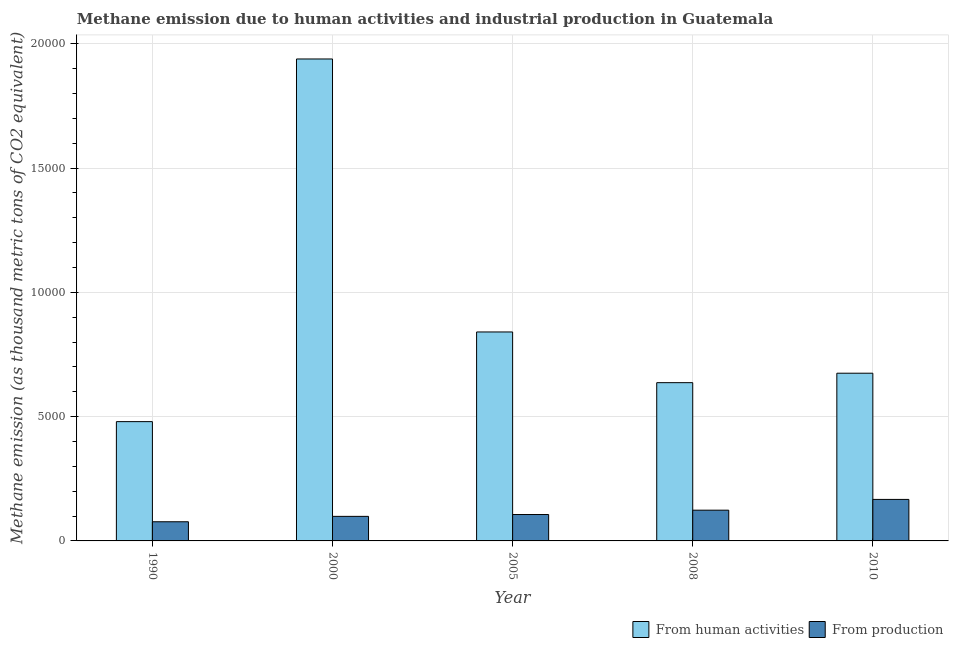How many different coloured bars are there?
Keep it short and to the point. 2. Are the number of bars per tick equal to the number of legend labels?
Your response must be concise. Yes. Are the number of bars on each tick of the X-axis equal?
Keep it short and to the point. Yes. How many bars are there on the 5th tick from the right?
Keep it short and to the point. 2. What is the label of the 3rd group of bars from the left?
Offer a very short reply. 2005. What is the amount of emissions from human activities in 2008?
Give a very brief answer. 6365.4. Across all years, what is the maximum amount of emissions from human activities?
Your response must be concise. 1.94e+04. Across all years, what is the minimum amount of emissions from human activities?
Give a very brief answer. 4798.4. In which year was the amount of emissions from human activities minimum?
Ensure brevity in your answer.  1990. What is the total amount of emissions from human activities in the graph?
Offer a very short reply. 4.57e+04. What is the difference between the amount of emissions from human activities in 2000 and that in 2005?
Ensure brevity in your answer.  1.10e+04. What is the difference between the amount of emissions from human activities in 2005 and the amount of emissions generated from industries in 2010?
Provide a short and direct response. 1659.2. What is the average amount of emissions from human activities per year?
Your answer should be compact. 9140. What is the ratio of the amount of emissions from human activities in 1990 to that in 2005?
Give a very brief answer. 0.57. Is the amount of emissions from human activities in 1990 less than that in 2000?
Give a very brief answer. Yes. Is the difference between the amount of emissions generated from industries in 1990 and 2008 greater than the difference between the amount of emissions from human activities in 1990 and 2008?
Make the answer very short. No. What is the difference between the highest and the second highest amount of emissions generated from industries?
Provide a short and direct response. 432.8. What is the difference between the highest and the lowest amount of emissions generated from industries?
Ensure brevity in your answer.  898.7. What does the 1st bar from the left in 1990 represents?
Offer a very short reply. From human activities. What does the 1st bar from the right in 1990 represents?
Offer a very short reply. From production. How many bars are there?
Make the answer very short. 10. What is the difference between two consecutive major ticks on the Y-axis?
Your answer should be compact. 5000. Are the values on the major ticks of Y-axis written in scientific E-notation?
Your answer should be very brief. No. Does the graph contain any zero values?
Make the answer very short. No. What is the title of the graph?
Your answer should be very brief. Methane emission due to human activities and industrial production in Guatemala. Does "Agricultural land" appear as one of the legend labels in the graph?
Your answer should be very brief. No. What is the label or title of the X-axis?
Your answer should be compact. Year. What is the label or title of the Y-axis?
Provide a succinct answer. Methane emission (as thousand metric tons of CO2 equivalent). What is the Methane emission (as thousand metric tons of CO2 equivalent) in From human activities in 1990?
Your response must be concise. 4798.4. What is the Methane emission (as thousand metric tons of CO2 equivalent) of From production in 1990?
Make the answer very short. 770.6. What is the Methane emission (as thousand metric tons of CO2 equivalent) in From human activities in 2000?
Keep it short and to the point. 1.94e+04. What is the Methane emission (as thousand metric tons of CO2 equivalent) of From production in 2000?
Your answer should be very brief. 987.9. What is the Methane emission (as thousand metric tons of CO2 equivalent) of From human activities in 2005?
Your answer should be very brief. 8404.9. What is the Methane emission (as thousand metric tons of CO2 equivalent) in From production in 2005?
Your answer should be very brief. 1062. What is the Methane emission (as thousand metric tons of CO2 equivalent) in From human activities in 2008?
Make the answer very short. 6365.4. What is the Methane emission (as thousand metric tons of CO2 equivalent) of From production in 2008?
Your answer should be compact. 1236.5. What is the Methane emission (as thousand metric tons of CO2 equivalent) of From human activities in 2010?
Provide a short and direct response. 6745.7. What is the Methane emission (as thousand metric tons of CO2 equivalent) in From production in 2010?
Your response must be concise. 1669.3. Across all years, what is the maximum Methane emission (as thousand metric tons of CO2 equivalent) of From human activities?
Your answer should be very brief. 1.94e+04. Across all years, what is the maximum Methane emission (as thousand metric tons of CO2 equivalent) of From production?
Provide a succinct answer. 1669.3. Across all years, what is the minimum Methane emission (as thousand metric tons of CO2 equivalent) of From human activities?
Make the answer very short. 4798.4. Across all years, what is the minimum Methane emission (as thousand metric tons of CO2 equivalent) of From production?
Your answer should be compact. 770.6. What is the total Methane emission (as thousand metric tons of CO2 equivalent) in From human activities in the graph?
Provide a succinct answer. 4.57e+04. What is the total Methane emission (as thousand metric tons of CO2 equivalent) of From production in the graph?
Offer a terse response. 5726.3. What is the difference between the Methane emission (as thousand metric tons of CO2 equivalent) in From human activities in 1990 and that in 2000?
Your response must be concise. -1.46e+04. What is the difference between the Methane emission (as thousand metric tons of CO2 equivalent) in From production in 1990 and that in 2000?
Keep it short and to the point. -217.3. What is the difference between the Methane emission (as thousand metric tons of CO2 equivalent) in From human activities in 1990 and that in 2005?
Your response must be concise. -3606.5. What is the difference between the Methane emission (as thousand metric tons of CO2 equivalent) of From production in 1990 and that in 2005?
Offer a terse response. -291.4. What is the difference between the Methane emission (as thousand metric tons of CO2 equivalent) of From human activities in 1990 and that in 2008?
Offer a terse response. -1567. What is the difference between the Methane emission (as thousand metric tons of CO2 equivalent) in From production in 1990 and that in 2008?
Offer a very short reply. -465.9. What is the difference between the Methane emission (as thousand metric tons of CO2 equivalent) in From human activities in 1990 and that in 2010?
Make the answer very short. -1947.3. What is the difference between the Methane emission (as thousand metric tons of CO2 equivalent) in From production in 1990 and that in 2010?
Your answer should be compact. -898.7. What is the difference between the Methane emission (as thousand metric tons of CO2 equivalent) of From human activities in 2000 and that in 2005?
Offer a terse response. 1.10e+04. What is the difference between the Methane emission (as thousand metric tons of CO2 equivalent) of From production in 2000 and that in 2005?
Keep it short and to the point. -74.1. What is the difference between the Methane emission (as thousand metric tons of CO2 equivalent) in From human activities in 2000 and that in 2008?
Your answer should be very brief. 1.30e+04. What is the difference between the Methane emission (as thousand metric tons of CO2 equivalent) in From production in 2000 and that in 2008?
Provide a succinct answer. -248.6. What is the difference between the Methane emission (as thousand metric tons of CO2 equivalent) of From human activities in 2000 and that in 2010?
Your response must be concise. 1.26e+04. What is the difference between the Methane emission (as thousand metric tons of CO2 equivalent) in From production in 2000 and that in 2010?
Your response must be concise. -681.4. What is the difference between the Methane emission (as thousand metric tons of CO2 equivalent) in From human activities in 2005 and that in 2008?
Keep it short and to the point. 2039.5. What is the difference between the Methane emission (as thousand metric tons of CO2 equivalent) of From production in 2005 and that in 2008?
Provide a short and direct response. -174.5. What is the difference between the Methane emission (as thousand metric tons of CO2 equivalent) in From human activities in 2005 and that in 2010?
Your response must be concise. 1659.2. What is the difference between the Methane emission (as thousand metric tons of CO2 equivalent) of From production in 2005 and that in 2010?
Give a very brief answer. -607.3. What is the difference between the Methane emission (as thousand metric tons of CO2 equivalent) of From human activities in 2008 and that in 2010?
Offer a very short reply. -380.3. What is the difference between the Methane emission (as thousand metric tons of CO2 equivalent) of From production in 2008 and that in 2010?
Ensure brevity in your answer.  -432.8. What is the difference between the Methane emission (as thousand metric tons of CO2 equivalent) of From human activities in 1990 and the Methane emission (as thousand metric tons of CO2 equivalent) of From production in 2000?
Provide a short and direct response. 3810.5. What is the difference between the Methane emission (as thousand metric tons of CO2 equivalent) in From human activities in 1990 and the Methane emission (as thousand metric tons of CO2 equivalent) in From production in 2005?
Provide a short and direct response. 3736.4. What is the difference between the Methane emission (as thousand metric tons of CO2 equivalent) of From human activities in 1990 and the Methane emission (as thousand metric tons of CO2 equivalent) of From production in 2008?
Offer a terse response. 3561.9. What is the difference between the Methane emission (as thousand metric tons of CO2 equivalent) in From human activities in 1990 and the Methane emission (as thousand metric tons of CO2 equivalent) in From production in 2010?
Your response must be concise. 3129.1. What is the difference between the Methane emission (as thousand metric tons of CO2 equivalent) of From human activities in 2000 and the Methane emission (as thousand metric tons of CO2 equivalent) of From production in 2005?
Offer a very short reply. 1.83e+04. What is the difference between the Methane emission (as thousand metric tons of CO2 equivalent) in From human activities in 2000 and the Methane emission (as thousand metric tons of CO2 equivalent) in From production in 2008?
Offer a very short reply. 1.81e+04. What is the difference between the Methane emission (as thousand metric tons of CO2 equivalent) in From human activities in 2000 and the Methane emission (as thousand metric tons of CO2 equivalent) in From production in 2010?
Offer a very short reply. 1.77e+04. What is the difference between the Methane emission (as thousand metric tons of CO2 equivalent) in From human activities in 2005 and the Methane emission (as thousand metric tons of CO2 equivalent) in From production in 2008?
Make the answer very short. 7168.4. What is the difference between the Methane emission (as thousand metric tons of CO2 equivalent) in From human activities in 2005 and the Methane emission (as thousand metric tons of CO2 equivalent) in From production in 2010?
Your response must be concise. 6735.6. What is the difference between the Methane emission (as thousand metric tons of CO2 equivalent) of From human activities in 2008 and the Methane emission (as thousand metric tons of CO2 equivalent) of From production in 2010?
Ensure brevity in your answer.  4696.1. What is the average Methane emission (as thousand metric tons of CO2 equivalent) in From human activities per year?
Keep it short and to the point. 9140. What is the average Methane emission (as thousand metric tons of CO2 equivalent) of From production per year?
Provide a succinct answer. 1145.26. In the year 1990, what is the difference between the Methane emission (as thousand metric tons of CO2 equivalent) in From human activities and Methane emission (as thousand metric tons of CO2 equivalent) in From production?
Your answer should be very brief. 4027.8. In the year 2000, what is the difference between the Methane emission (as thousand metric tons of CO2 equivalent) of From human activities and Methane emission (as thousand metric tons of CO2 equivalent) of From production?
Your response must be concise. 1.84e+04. In the year 2005, what is the difference between the Methane emission (as thousand metric tons of CO2 equivalent) in From human activities and Methane emission (as thousand metric tons of CO2 equivalent) in From production?
Provide a succinct answer. 7342.9. In the year 2008, what is the difference between the Methane emission (as thousand metric tons of CO2 equivalent) in From human activities and Methane emission (as thousand metric tons of CO2 equivalent) in From production?
Offer a very short reply. 5128.9. In the year 2010, what is the difference between the Methane emission (as thousand metric tons of CO2 equivalent) in From human activities and Methane emission (as thousand metric tons of CO2 equivalent) in From production?
Ensure brevity in your answer.  5076.4. What is the ratio of the Methane emission (as thousand metric tons of CO2 equivalent) of From human activities in 1990 to that in 2000?
Offer a terse response. 0.25. What is the ratio of the Methane emission (as thousand metric tons of CO2 equivalent) in From production in 1990 to that in 2000?
Provide a succinct answer. 0.78. What is the ratio of the Methane emission (as thousand metric tons of CO2 equivalent) of From human activities in 1990 to that in 2005?
Offer a terse response. 0.57. What is the ratio of the Methane emission (as thousand metric tons of CO2 equivalent) of From production in 1990 to that in 2005?
Give a very brief answer. 0.73. What is the ratio of the Methane emission (as thousand metric tons of CO2 equivalent) in From human activities in 1990 to that in 2008?
Your response must be concise. 0.75. What is the ratio of the Methane emission (as thousand metric tons of CO2 equivalent) of From production in 1990 to that in 2008?
Offer a terse response. 0.62. What is the ratio of the Methane emission (as thousand metric tons of CO2 equivalent) in From human activities in 1990 to that in 2010?
Provide a succinct answer. 0.71. What is the ratio of the Methane emission (as thousand metric tons of CO2 equivalent) in From production in 1990 to that in 2010?
Offer a very short reply. 0.46. What is the ratio of the Methane emission (as thousand metric tons of CO2 equivalent) in From human activities in 2000 to that in 2005?
Give a very brief answer. 2.31. What is the ratio of the Methane emission (as thousand metric tons of CO2 equivalent) of From production in 2000 to that in 2005?
Provide a short and direct response. 0.93. What is the ratio of the Methane emission (as thousand metric tons of CO2 equivalent) in From human activities in 2000 to that in 2008?
Offer a terse response. 3.05. What is the ratio of the Methane emission (as thousand metric tons of CO2 equivalent) in From production in 2000 to that in 2008?
Ensure brevity in your answer.  0.8. What is the ratio of the Methane emission (as thousand metric tons of CO2 equivalent) in From human activities in 2000 to that in 2010?
Make the answer very short. 2.87. What is the ratio of the Methane emission (as thousand metric tons of CO2 equivalent) of From production in 2000 to that in 2010?
Offer a very short reply. 0.59. What is the ratio of the Methane emission (as thousand metric tons of CO2 equivalent) of From human activities in 2005 to that in 2008?
Give a very brief answer. 1.32. What is the ratio of the Methane emission (as thousand metric tons of CO2 equivalent) of From production in 2005 to that in 2008?
Your response must be concise. 0.86. What is the ratio of the Methane emission (as thousand metric tons of CO2 equivalent) in From human activities in 2005 to that in 2010?
Ensure brevity in your answer.  1.25. What is the ratio of the Methane emission (as thousand metric tons of CO2 equivalent) in From production in 2005 to that in 2010?
Your answer should be very brief. 0.64. What is the ratio of the Methane emission (as thousand metric tons of CO2 equivalent) of From human activities in 2008 to that in 2010?
Your answer should be very brief. 0.94. What is the ratio of the Methane emission (as thousand metric tons of CO2 equivalent) in From production in 2008 to that in 2010?
Keep it short and to the point. 0.74. What is the difference between the highest and the second highest Methane emission (as thousand metric tons of CO2 equivalent) of From human activities?
Your answer should be very brief. 1.10e+04. What is the difference between the highest and the second highest Methane emission (as thousand metric tons of CO2 equivalent) of From production?
Offer a very short reply. 432.8. What is the difference between the highest and the lowest Methane emission (as thousand metric tons of CO2 equivalent) in From human activities?
Your answer should be compact. 1.46e+04. What is the difference between the highest and the lowest Methane emission (as thousand metric tons of CO2 equivalent) in From production?
Give a very brief answer. 898.7. 